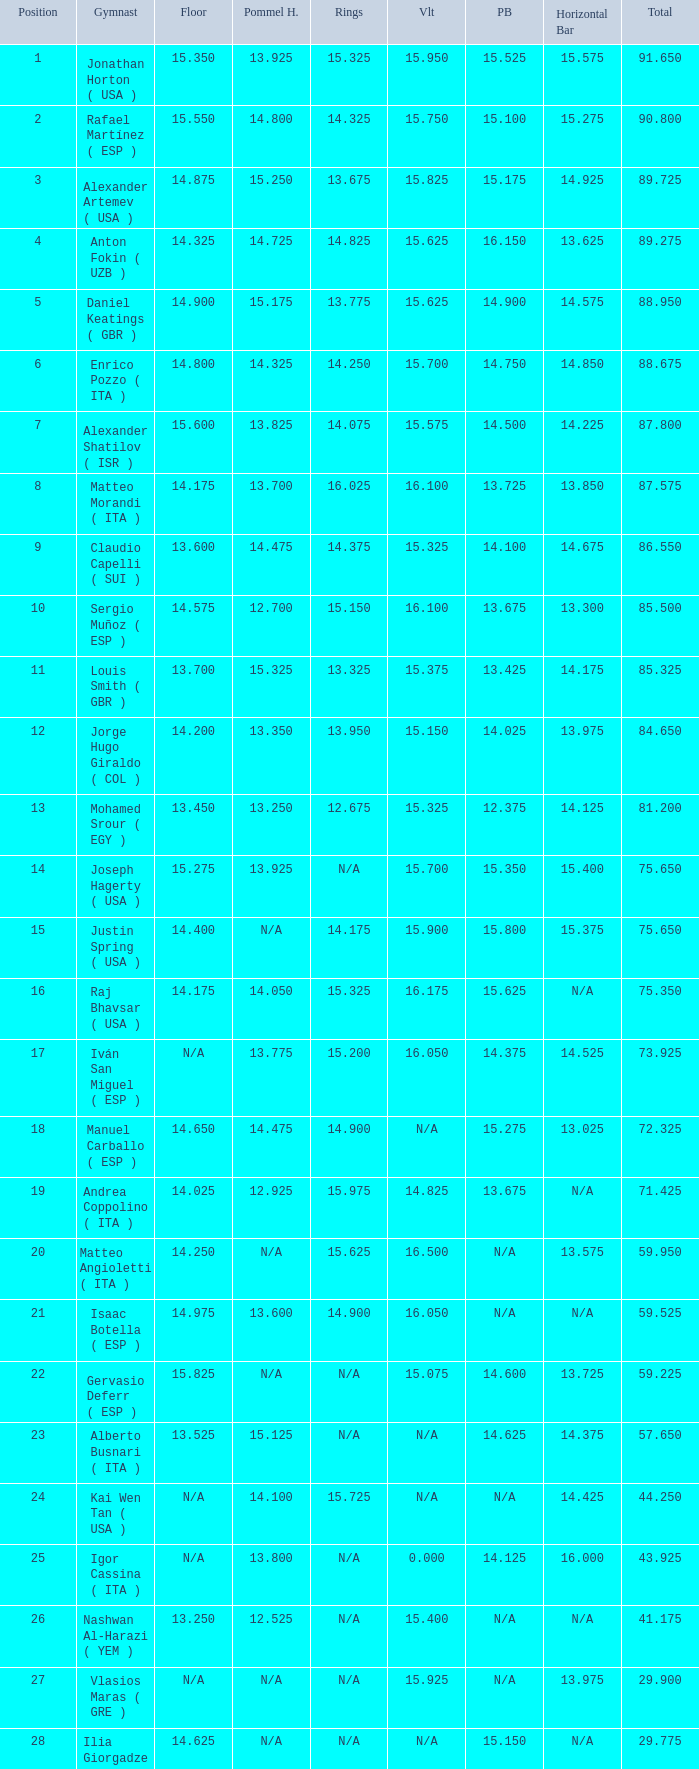If the parallel bars is 14.025, what is the total number of gymnasts? 1.0. 